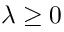Convert formula to latex. <formula><loc_0><loc_0><loc_500><loc_500>\lambda \geq 0</formula> 